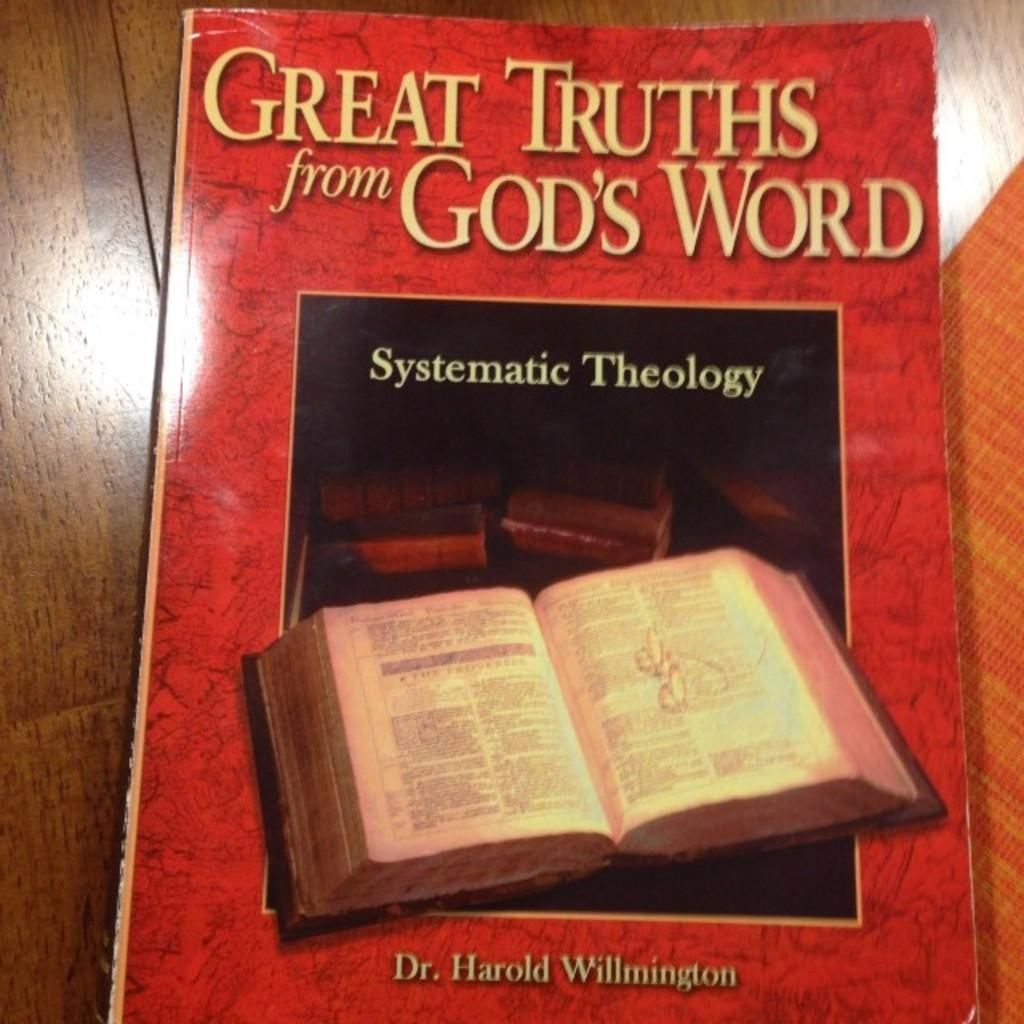<image>
Write a terse but informative summary of the picture. A book on theology is sitting on a wooden surface. 